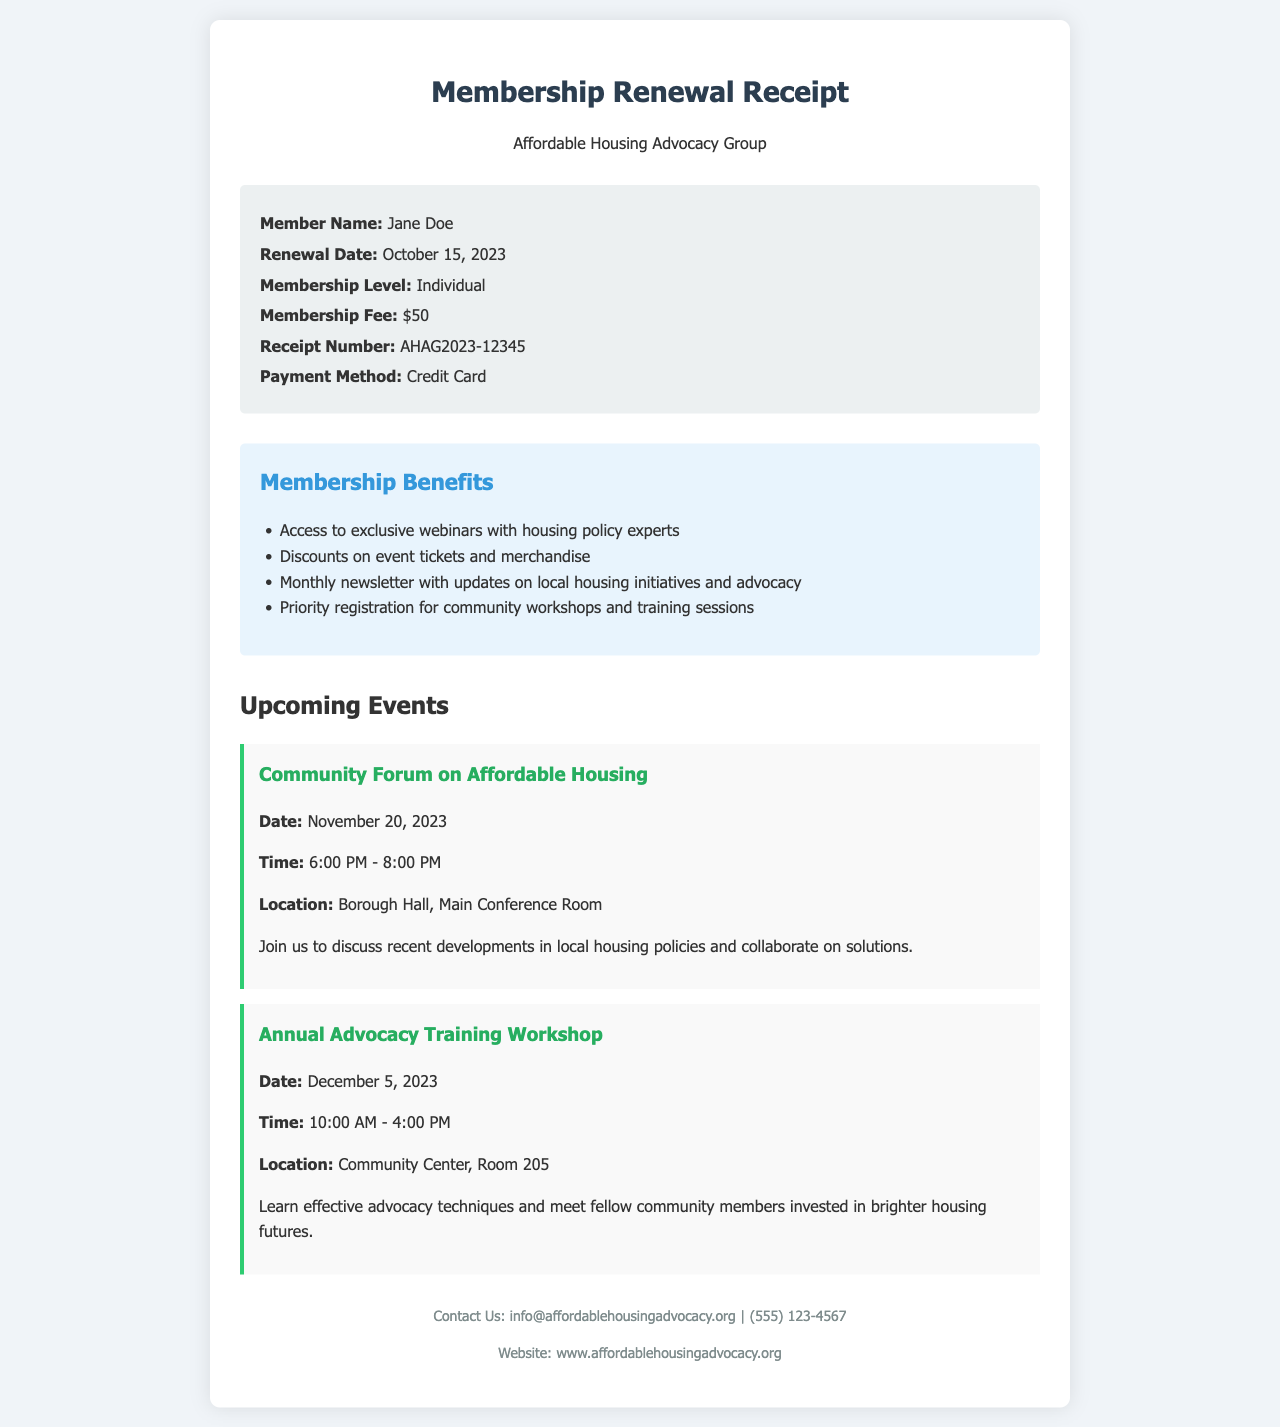What is the member's name? The member's name is specified in the receipt details section of the document.
Answer: Jane Doe What is the renewal date? The renewal date is mentioned in the receipt details section.
Answer: October 15, 2023 What is the membership fee? The membership fee is clearly stated in the receipt details.
Answer: $50 What are the benefits of membership? Membership benefits are outlined in a list under the membership benefits section.
Answer: Access to exclusive webinars with housing policy experts When is the Community Forum on Affordable Housing? The date of the event is listed under Upcoming Events.
Answer: November 20, 2023 What time does the Annual Advocacy Training Workshop start? The start time is provided for the workshop in the events section.
Answer: 10:00 AM What payment method was used? The payment method is indicated in the receipt details.
Answer: Credit Card How can I contact the advocacy group? Contact information is provided in the footer of the document.
Answer: info@affordablehousingadvocacy.org What is the location of the Community Forum? The location for the forum is specified in the event details.
Answer: Borough Hall, Main Conference Room 